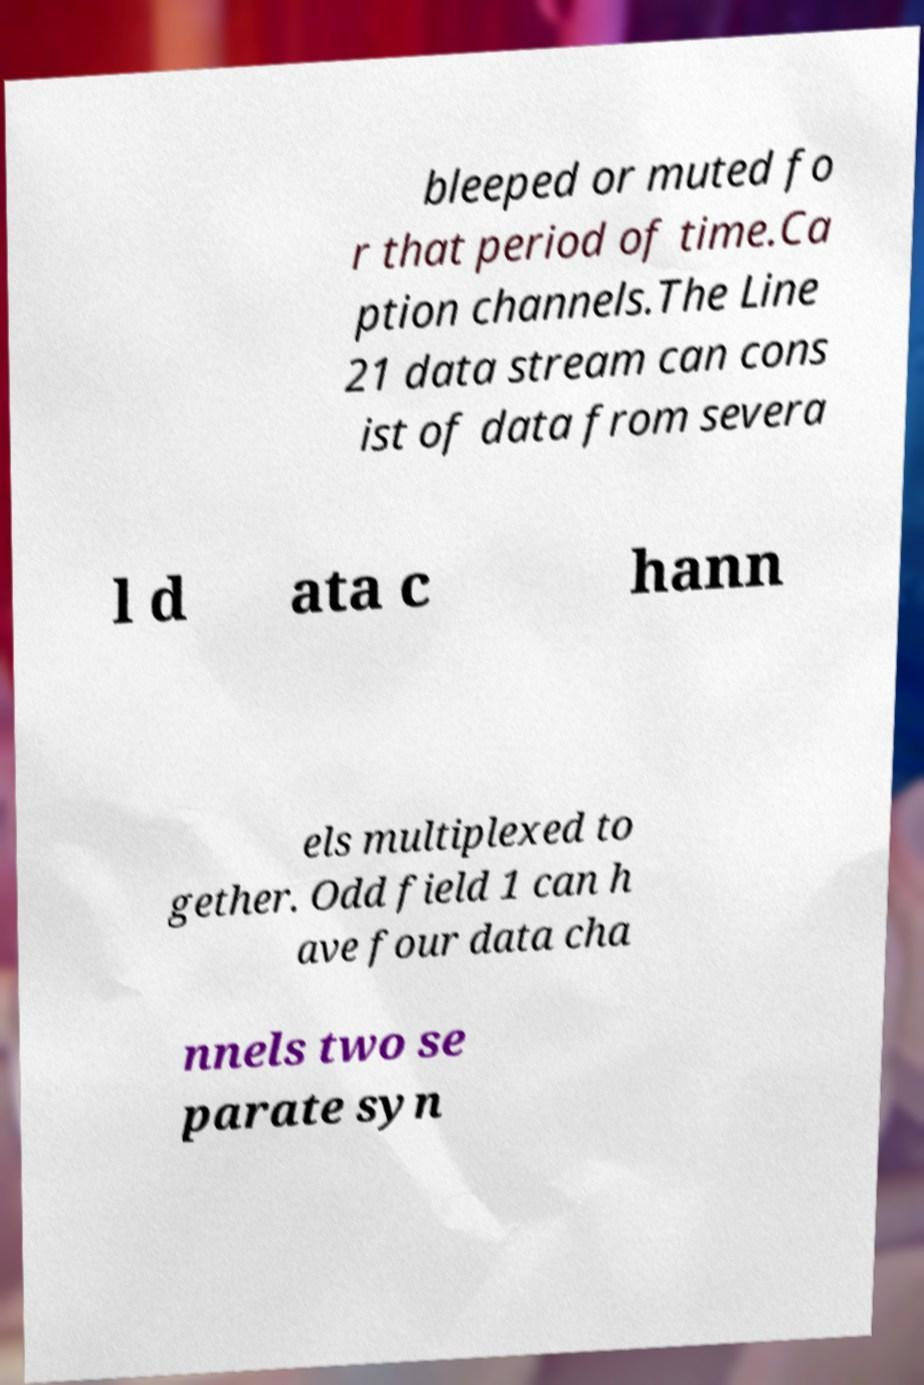Please identify and transcribe the text found in this image. bleeped or muted fo r that period of time.Ca ption channels.The Line 21 data stream can cons ist of data from severa l d ata c hann els multiplexed to gether. Odd field 1 can h ave four data cha nnels two se parate syn 